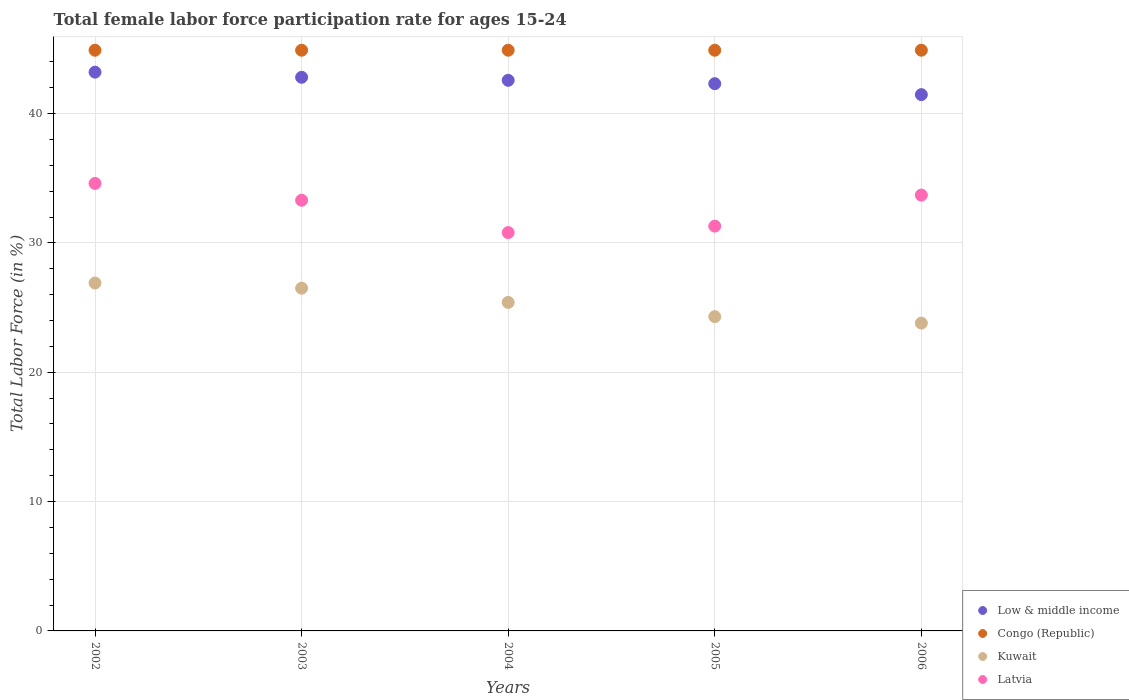How many different coloured dotlines are there?
Your response must be concise. 4. What is the female labor force participation rate in Low & middle income in 2005?
Your response must be concise. 42.31. Across all years, what is the maximum female labor force participation rate in Congo (Republic)?
Make the answer very short. 44.9. Across all years, what is the minimum female labor force participation rate in Kuwait?
Keep it short and to the point. 23.8. In which year was the female labor force participation rate in Kuwait maximum?
Your answer should be compact. 2002. What is the total female labor force participation rate in Congo (Republic) in the graph?
Provide a short and direct response. 224.5. What is the difference between the female labor force participation rate in Low & middle income in 2004 and that in 2006?
Make the answer very short. 1.11. What is the difference between the female labor force participation rate in Congo (Republic) in 2006 and the female labor force participation rate in Low & middle income in 2004?
Give a very brief answer. 2.33. What is the average female labor force participation rate in Low & middle income per year?
Offer a very short reply. 42.47. In the year 2006, what is the difference between the female labor force participation rate in Congo (Republic) and female labor force participation rate in Low & middle income?
Your answer should be very brief. 3.43. In how many years, is the female labor force participation rate in Congo (Republic) greater than 30 %?
Keep it short and to the point. 5. What is the ratio of the female labor force participation rate in Low & middle income in 2003 to that in 2004?
Offer a terse response. 1.01. What is the difference between the highest and the second highest female labor force participation rate in Congo (Republic)?
Offer a very short reply. 0. What is the difference between the highest and the lowest female labor force participation rate in Congo (Republic)?
Offer a very short reply. 0. In how many years, is the female labor force participation rate in Kuwait greater than the average female labor force participation rate in Kuwait taken over all years?
Provide a succinct answer. 3. Does the female labor force participation rate in Latvia monotonically increase over the years?
Provide a short and direct response. No. Is the female labor force participation rate in Kuwait strictly greater than the female labor force participation rate in Congo (Republic) over the years?
Provide a succinct answer. No. Does the graph contain any zero values?
Ensure brevity in your answer.  No. Does the graph contain grids?
Ensure brevity in your answer.  Yes. How are the legend labels stacked?
Your answer should be very brief. Vertical. What is the title of the graph?
Provide a short and direct response. Total female labor force participation rate for ages 15-24. What is the label or title of the Y-axis?
Your response must be concise. Total Labor Force (in %). What is the Total Labor Force (in %) of Low & middle income in 2002?
Your answer should be very brief. 43.2. What is the Total Labor Force (in %) in Congo (Republic) in 2002?
Give a very brief answer. 44.9. What is the Total Labor Force (in %) in Kuwait in 2002?
Ensure brevity in your answer.  26.9. What is the Total Labor Force (in %) of Latvia in 2002?
Your answer should be very brief. 34.6. What is the Total Labor Force (in %) of Low & middle income in 2003?
Your response must be concise. 42.81. What is the Total Labor Force (in %) of Congo (Republic) in 2003?
Your answer should be very brief. 44.9. What is the Total Labor Force (in %) in Latvia in 2003?
Ensure brevity in your answer.  33.3. What is the Total Labor Force (in %) of Low & middle income in 2004?
Ensure brevity in your answer.  42.57. What is the Total Labor Force (in %) in Congo (Republic) in 2004?
Your response must be concise. 44.9. What is the Total Labor Force (in %) of Kuwait in 2004?
Your answer should be compact. 25.4. What is the Total Labor Force (in %) in Latvia in 2004?
Offer a very short reply. 30.8. What is the Total Labor Force (in %) of Low & middle income in 2005?
Provide a succinct answer. 42.31. What is the Total Labor Force (in %) of Congo (Republic) in 2005?
Your response must be concise. 44.9. What is the Total Labor Force (in %) of Kuwait in 2005?
Provide a short and direct response. 24.3. What is the Total Labor Force (in %) in Latvia in 2005?
Your response must be concise. 31.3. What is the Total Labor Force (in %) in Low & middle income in 2006?
Make the answer very short. 41.47. What is the Total Labor Force (in %) of Congo (Republic) in 2006?
Keep it short and to the point. 44.9. What is the Total Labor Force (in %) of Kuwait in 2006?
Give a very brief answer. 23.8. What is the Total Labor Force (in %) in Latvia in 2006?
Provide a succinct answer. 33.7. Across all years, what is the maximum Total Labor Force (in %) in Low & middle income?
Offer a terse response. 43.2. Across all years, what is the maximum Total Labor Force (in %) of Congo (Republic)?
Your answer should be very brief. 44.9. Across all years, what is the maximum Total Labor Force (in %) in Kuwait?
Keep it short and to the point. 26.9. Across all years, what is the maximum Total Labor Force (in %) of Latvia?
Ensure brevity in your answer.  34.6. Across all years, what is the minimum Total Labor Force (in %) in Low & middle income?
Ensure brevity in your answer.  41.47. Across all years, what is the minimum Total Labor Force (in %) of Congo (Republic)?
Keep it short and to the point. 44.9. Across all years, what is the minimum Total Labor Force (in %) in Kuwait?
Your answer should be compact. 23.8. Across all years, what is the minimum Total Labor Force (in %) of Latvia?
Your answer should be very brief. 30.8. What is the total Total Labor Force (in %) of Low & middle income in the graph?
Make the answer very short. 212.36. What is the total Total Labor Force (in %) of Congo (Republic) in the graph?
Provide a short and direct response. 224.5. What is the total Total Labor Force (in %) in Kuwait in the graph?
Offer a terse response. 126.9. What is the total Total Labor Force (in %) of Latvia in the graph?
Your answer should be compact. 163.7. What is the difference between the Total Labor Force (in %) of Low & middle income in 2002 and that in 2003?
Ensure brevity in your answer.  0.4. What is the difference between the Total Labor Force (in %) of Latvia in 2002 and that in 2003?
Your answer should be very brief. 1.3. What is the difference between the Total Labor Force (in %) of Low & middle income in 2002 and that in 2004?
Your response must be concise. 0.63. What is the difference between the Total Labor Force (in %) of Congo (Republic) in 2002 and that in 2004?
Offer a terse response. 0. What is the difference between the Total Labor Force (in %) of Kuwait in 2002 and that in 2004?
Provide a succinct answer. 1.5. What is the difference between the Total Labor Force (in %) in Latvia in 2002 and that in 2004?
Give a very brief answer. 3.8. What is the difference between the Total Labor Force (in %) of Low & middle income in 2002 and that in 2005?
Offer a very short reply. 0.89. What is the difference between the Total Labor Force (in %) of Kuwait in 2002 and that in 2005?
Keep it short and to the point. 2.6. What is the difference between the Total Labor Force (in %) of Latvia in 2002 and that in 2005?
Ensure brevity in your answer.  3.3. What is the difference between the Total Labor Force (in %) in Low & middle income in 2002 and that in 2006?
Provide a short and direct response. 1.74. What is the difference between the Total Labor Force (in %) of Congo (Republic) in 2002 and that in 2006?
Ensure brevity in your answer.  0. What is the difference between the Total Labor Force (in %) of Latvia in 2002 and that in 2006?
Offer a terse response. 0.9. What is the difference between the Total Labor Force (in %) of Low & middle income in 2003 and that in 2004?
Your answer should be compact. 0.23. What is the difference between the Total Labor Force (in %) of Kuwait in 2003 and that in 2004?
Make the answer very short. 1.1. What is the difference between the Total Labor Force (in %) in Low & middle income in 2003 and that in 2005?
Your answer should be very brief. 0.49. What is the difference between the Total Labor Force (in %) of Congo (Republic) in 2003 and that in 2005?
Provide a succinct answer. 0. What is the difference between the Total Labor Force (in %) in Latvia in 2003 and that in 2005?
Provide a succinct answer. 2. What is the difference between the Total Labor Force (in %) of Low & middle income in 2003 and that in 2006?
Provide a succinct answer. 1.34. What is the difference between the Total Labor Force (in %) in Congo (Republic) in 2003 and that in 2006?
Your answer should be very brief. 0. What is the difference between the Total Labor Force (in %) of Kuwait in 2003 and that in 2006?
Ensure brevity in your answer.  2.7. What is the difference between the Total Labor Force (in %) in Latvia in 2003 and that in 2006?
Offer a terse response. -0.4. What is the difference between the Total Labor Force (in %) in Low & middle income in 2004 and that in 2005?
Ensure brevity in your answer.  0.26. What is the difference between the Total Labor Force (in %) of Congo (Republic) in 2004 and that in 2005?
Your answer should be compact. 0. What is the difference between the Total Labor Force (in %) of Kuwait in 2004 and that in 2005?
Provide a succinct answer. 1.1. What is the difference between the Total Labor Force (in %) in Low & middle income in 2004 and that in 2006?
Offer a terse response. 1.11. What is the difference between the Total Labor Force (in %) in Congo (Republic) in 2004 and that in 2006?
Offer a terse response. 0. What is the difference between the Total Labor Force (in %) in Kuwait in 2004 and that in 2006?
Your answer should be compact. 1.6. What is the difference between the Total Labor Force (in %) in Latvia in 2004 and that in 2006?
Provide a short and direct response. -2.9. What is the difference between the Total Labor Force (in %) in Low & middle income in 2005 and that in 2006?
Ensure brevity in your answer.  0.85. What is the difference between the Total Labor Force (in %) in Congo (Republic) in 2005 and that in 2006?
Your answer should be compact. 0. What is the difference between the Total Labor Force (in %) in Latvia in 2005 and that in 2006?
Your answer should be very brief. -2.4. What is the difference between the Total Labor Force (in %) in Low & middle income in 2002 and the Total Labor Force (in %) in Congo (Republic) in 2003?
Your answer should be very brief. -1.7. What is the difference between the Total Labor Force (in %) in Low & middle income in 2002 and the Total Labor Force (in %) in Kuwait in 2003?
Give a very brief answer. 16.7. What is the difference between the Total Labor Force (in %) in Low & middle income in 2002 and the Total Labor Force (in %) in Latvia in 2003?
Keep it short and to the point. 9.9. What is the difference between the Total Labor Force (in %) of Congo (Republic) in 2002 and the Total Labor Force (in %) of Latvia in 2003?
Your answer should be compact. 11.6. What is the difference between the Total Labor Force (in %) in Kuwait in 2002 and the Total Labor Force (in %) in Latvia in 2003?
Give a very brief answer. -6.4. What is the difference between the Total Labor Force (in %) in Low & middle income in 2002 and the Total Labor Force (in %) in Congo (Republic) in 2004?
Provide a succinct answer. -1.7. What is the difference between the Total Labor Force (in %) in Low & middle income in 2002 and the Total Labor Force (in %) in Kuwait in 2004?
Ensure brevity in your answer.  17.8. What is the difference between the Total Labor Force (in %) in Low & middle income in 2002 and the Total Labor Force (in %) in Latvia in 2004?
Provide a succinct answer. 12.4. What is the difference between the Total Labor Force (in %) of Kuwait in 2002 and the Total Labor Force (in %) of Latvia in 2004?
Provide a short and direct response. -3.9. What is the difference between the Total Labor Force (in %) of Low & middle income in 2002 and the Total Labor Force (in %) of Congo (Republic) in 2005?
Ensure brevity in your answer.  -1.7. What is the difference between the Total Labor Force (in %) in Low & middle income in 2002 and the Total Labor Force (in %) in Kuwait in 2005?
Provide a short and direct response. 18.9. What is the difference between the Total Labor Force (in %) in Low & middle income in 2002 and the Total Labor Force (in %) in Latvia in 2005?
Keep it short and to the point. 11.9. What is the difference between the Total Labor Force (in %) of Congo (Republic) in 2002 and the Total Labor Force (in %) of Kuwait in 2005?
Your answer should be very brief. 20.6. What is the difference between the Total Labor Force (in %) of Kuwait in 2002 and the Total Labor Force (in %) of Latvia in 2005?
Provide a short and direct response. -4.4. What is the difference between the Total Labor Force (in %) in Low & middle income in 2002 and the Total Labor Force (in %) in Congo (Republic) in 2006?
Provide a short and direct response. -1.7. What is the difference between the Total Labor Force (in %) in Low & middle income in 2002 and the Total Labor Force (in %) in Kuwait in 2006?
Ensure brevity in your answer.  19.4. What is the difference between the Total Labor Force (in %) in Low & middle income in 2002 and the Total Labor Force (in %) in Latvia in 2006?
Provide a short and direct response. 9.5. What is the difference between the Total Labor Force (in %) in Congo (Republic) in 2002 and the Total Labor Force (in %) in Kuwait in 2006?
Keep it short and to the point. 21.1. What is the difference between the Total Labor Force (in %) in Congo (Republic) in 2002 and the Total Labor Force (in %) in Latvia in 2006?
Provide a succinct answer. 11.2. What is the difference between the Total Labor Force (in %) in Low & middle income in 2003 and the Total Labor Force (in %) in Congo (Republic) in 2004?
Keep it short and to the point. -2.09. What is the difference between the Total Labor Force (in %) of Low & middle income in 2003 and the Total Labor Force (in %) of Kuwait in 2004?
Provide a succinct answer. 17.41. What is the difference between the Total Labor Force (in %) in Low & middle income in 2003 and the Total Labor Force (in %) in Latvia in 2004?
Offer a terse response. 12.01. What is the difference between the Total Labor Force (in %) in Congo (Republic) in 2003 and the Total Labor Force (in %) in Latvia in 2004?
Make the answer very short. 14.1. What is the difference between the Total Labor Force (in %) of Low & middle income in 2003 and the Total Labor Force (in %) of Congo (Republic) in 2005?
Your answer should be very brief. -2.09. What is the difference between the Total Labor Force (in %) in Low & middle income in 2003 and the Total Labor Force (in %) in Kuwait in 2005?
Your response must be concise. 18.51. What is the difference between the Total Labor Force (in %) of Low & middle income in 2003 and the Total Labor Force (in %) of Latvia in 2005?
Provide a succinct answer. 11.51. What is the difference between the Total Labor Force (in %) of Congo (Republic) in 2003 and the Total Labor Force (in %) of Kuwait in 2005?
Give a very brief answer. 20.6. What is the difference between the Total Labor Force (in %) of Congo (Republic) in 2003 and the Total Labor Force (in %) of Latvia in 2005?
Provide a succinct answer. 13.6. What is the difference between the Total Labor Force (in %) of Kuwait in 2003 and the Total Labor Force (in %) of Latvia in 2005?
Offer a terse response. -4.8. What is the difference between the Total Labor Force (in %) in Low & middle income in 2003 and the Total Labor Force (in %) in Congo (Republic) in 2006?
Provide a succinct answer. -2.09. What is the difference between the Total Labor Force (in %) of Low & middle income in 2003 and the Total Labor Force (in %) of Kuwait in 2006?
Your answer should be very brief. 19.01. What is the difference between the Total Labor Force (in %) in Low & middle income in 2003 and the Total Labor Force (in %) in Latvia in 2006?
Keep it short and to the point. 9.11. What is the difference between the Total Labor Force (in %) in Congo (Republic) in 2003 and the Total Labor Force (in %) in Kuwait in 2006?
Provide a short and direct response. 21.1. What is the difference between the Total Labor Force (in %) in Congo (Republic) in 2003 and the Total Labor Force (in %) in Latvia in 2006?
Offer a terse response. 11.2. What is the difference between the Total Labor Force (in %) of Low & middle income in 2004 and the Total Labor Force (in %) of Congo (Republic) in 2005?
Your answer should be compact. -2.33. What is the difference between the Total Labor Force (in %) in Low & middle income in 2004 and the Total Labor Force (in %) in Kuwait in 2005?
Provide a succinct answer. 18.27. What is the difference between the Total Labor Force (in %) in Low & middle income in 2004 and the Total Labor Force (in %) in Latvia in 2005?
Your answer should be very brief. 11.27. What is the difference between the Total Labor Force (in %) of Congo (Republic) in 2004 and the Total Labor Force (in %) of Kuwait in 2005?
Make the answer very short. 20.6. What is the difference between the Total Labor Force (in %) in Congo (Republic) in 2004 and the Total Labor Force (in %) in Latvia in 2005?
Offer a terse response. 13.6. What is the difference between the Total Labor Force (in %) of Kuwait in 2004 and the Total Labor Force (in %) of Latvia in 2005?
Your answer should be very brief. -5.9. What is the difference between the Total Labor Force (in %) of Low & middle income in 2004 and the Total Labor Force (in %) of Congo (Republic) in 2006?
Provide a succinct answer. -2.33. What is the difference between the Total Labor Force (in %) in Low & middle income in 2004 and the Total Labor Force (in %) in Kuwait in 2006?
Offer a terse response. 18.77. What is the difference between the Total Labor Force (in %) in Low & middle income in 2004 and the Total Labor Force (in %) in Latvia in 2006?
Make the answer very short. 8.87. What is the difference between the Total Labor Force (in %) in Congo (Republic) in 2004 and the Total Labor Force (in %) in Kuwait in 2006?
Ensure brevity in your answer.  21.1. What is the difference between the Total Labor Force (in %) of Low & middle income in 2005 and the Total Labor Force (in %) of Congo (Republic) in 2006?
Your answer should be very brief. -2.59. What is the difference between the Total Labor Force (in %) of Low & middle income in 2005 and the Total Labor Force (in %) of Kuwait in 2006?
Give a very brief answer. 18.51. What is the difference between the Total Labor Force (in %) in Low & middle income in 2005 and the Total Labor Force (in %) in Latvia in 2006?
Give a very brief answer. 8.61. What is the difference between the Total Labor Force (in %) in Congo (Republic) in 2005 and the Total Labor Force (in %) in Kuwait in 2006?
Ensure brevity in your answer.  21.1. What is the difference between the Total Labor Force (in %) in Kuwait in 2005 and the Total Labor Force (in %) in Latvia in 2006?
Offer a very short reply. -9.4. What is the average Total Labor Force (in %) of Low & middle income per year?
Ensure brevity in your answer.  42.47. What is the average Total Labor Force (in %) of Congo (Republic) per year?
Ensure brevity in your answer.  44.9. What is the average Total Labor Force (in %) of Kuwait per year?
Your response must be concise. 25.38. What is the average Total Labor Force (in %) in Latvia per year?
Offer a very short reply. 32.74. In the year 2002, what is the difference between the Total Labor Force (in %) in Low & middle income and Total Labor Force (in %) in Congo (Republic)?
Offer a terse response. -1.7. In the year 2002, what is the difference between the Total Labor Force (in %) of Low & middle income and Total Labor Force (in %) of Kuwait?
Ensure brevity in your answer.  16.3. In the year 2002, what is the difference between the Total Labor Force (in %) in Low & middle income and Total Labor Force (in %) in Latvia?
Your answer should be compact. 8.6. In the year 2002, what is the difference between the Total Labor Force (in %) in Congo (Republic) and Total Labor Force (in %) in Kuwait?
Keep it short and to the point. 18. In the year 2002, what is the difference between the Total Labor Force (in %) of Kuwait and Total Labor Force (in %) of Latvia?
Keep it short and to the point. -7.7. In the year 2003, what is the difference between the Total Labor Force (in %) of Low & middle income and Total Labor Force (in %) of Congo (Republic)?
Provide a succinct answer. -2.09. In the year 2003, what is the difference between the Total Labor Force (in %) in Low & middle income and Total Labor Force (in %) in Kuwait?
Provide a short and direct response. 16.31. In the year 2003, what is the difference between the Total Labor Force (in %) in Low & middle income and Total Labor Force (in %) in Latvia?
Give a very brief answer. 9.51. In the year 2003, what is the difference between the Total Labor Force (in %) in Congo (Republic) and Total Labor Force (in %) in Kuwait?
Give a very brief answer. 18.4. In the year 2003, what is the difference between the Total Labor Force (in %) in Kuwait and Total Labor Force (in %) in Latvia?
Keep it short and to the point. -6.8. In the year 2004, what is the difference between the Total Labor Force (in %) of Low & middle income and Total Labor Force (in %) of Congo (Republic)?
Ensure brevity in your answer.  -2.33. In the year 2004, what is the difference between the Total Labor Force (in %) of Low & middle income and Total Labor Force (in %) of Kuwait?
Your answer should be very brief. 17.17. In the year 2004, what is the difference between the Total Labor Force (in %) of Low & middle income and Total Labor Force (in %) of Latvia?
Offer a terse response. 11.77. In the year 2004, what is the difference between the Total Labor Force (in %) in Congo (Republic) and Total Labor Force (in %) in Kuwait?
Offer a terse response. 19.5. In the year 2004, what is the difference between the Total Labor Force (in %) in Congo (Republic) and Total Labor Force (in %) in Latvia?
Your answer should be very brief. 14.1. In the year 2005, what is the difference between the Total Labor Force (in %) of Low & middle income and Total Labor Force (in %) of Congo (Republic)?
Ensure brevity in your answer.  -2.59. In the year 2005, what is the difference between the Total Labor Force (in %) in Low & middle income and Total Labor Force (in %) in Kuwait?
Provide a succinct answer. 18.01. In the year 2005, what is the difference between the Total Labor Force (in %) in Low & middle income and Total Labor Force (in %) in Latvia?
Provide a succinct answer. 11.01. In the year 2005, what is the difference between the Total Labor Force (in %) of Congo (Republic) and Total Labor Force (in %) of Kuwait?
Give a very brief answer. 20.6. In the year 2005, what is the difference between the Total Labor Force (in %) in Congo (Republic) and Total Labor Force (in %) in Latvia?
Provide a succinct answer. 13.6. In the year 2006, what is the difference between the Total Labor Force (in %) in Low & middle income and Total Labor Force (in %) in Congo (Republic)?
Provide a short and direct response. -3.43. In the year 2006, what is the difference between the Total Labor Force (in %) of Low & middle income and Total Labor Force (in %) of Kuwait?
Make the answer very short. 17.67. In the year 2006, what is the difference between the Total Labor Force (in %) of Low & middle income and Total Labor Force (in %) of Latvia?
Offer a terse response. 7.77. In the year 2006, what is the difference between the Total Labor Force (in %) in Congo (Republic) and Total Labor Force (in %) in Kuwait?
Your answer should be very brief. 21.1. What is the ratio of the Total Labor Force (in %) in Low & middle income in 2002 to that in 2003?
Your answer should be compact. 1.01. What is the ratio of the Total Labor Force (in %) in Kuwait in 2002 to that in 2003?
Ensure brevity in your answer.  1.02. What is the ratio of the Total Labor Force (in %) of Latvia in 2002 to that in 2003?
Your response must be concise. 1.04. What is the ratio of the Total Labor Force (in %) in Low & middle income in 2002 to that in 2004?
Offer a terse response. 1.01. What is the ratio of the Total Labor Force (in %) in Congo (Republic) in 2002 to that in 2004?
Keep it short and to the point. 1. What is the ratio of the Total Labor Force (in %) in Kuwait in 2002 to that in 2004?
Your answer should be very brief. 1.06. What is the ratio of the Total Labor Force (in %) of Latvia in 2002 to that in 2004?
Provide a succinct answer. 1.12. What is the ratio of the Total Labor Force (in %) in Low & middle income in 2002 to that in 2005?
Provide a succinct answer. 1.02. What is the ratio of the Total Labor Force (in %) in Congo (Republic) in 2002 to that in 2005?
Provide a succinct answer. 1. What is the ratio of the Total Labor Force (in %) in Kuwait in 2002 to that in 2005?
Make the answer very short. 1.11. What is the ratio of the Total Labor Force (in %) of Latvia in 2002 to that in 2005?
Make the answer very short. 1.11. What is the ratio of the Total Labor Force (in %) of Low & middle income in 2002 to that in 2006?
Your answer should be very brief. 1.04. What is the ratio of the Total Labor Force (in %) in Kuwait in 2002 to that in 2006?
Your answer should be very brief. 1.13. What is the ratio of the Total Labor Force (in %) in Latvia in 2002 to that in 2006?
Your response must be concise. 1.03. What is the ratio of the Total Labor Force (in %) of Kuwait in 2003 to that in 2004?
Your answer should be very brief. 1.04. What is the ratio of the Total Labor Force (in %) of Latvia in 2003 to that in 2004?
Offer a terse response. 1.08. What is the ratio of the Total Labor Force (in %) in Low & middle income in 2003 to that in 2005?
Offer a very short reply. 1.01. What is the ratio of the Total Labor Force (in %) of Kuwait in 2003 to that in 2005?
Offer a very short reply. 1.09. What is the ratio of the Total Labor Force (in %) in Latvia in 2003 to that in 2005?
Your response must be concise. 1.06. What is the ratio of the Total Labor Force (in %) in Low & middle income in 2003 to that in 2006?
Ensure brevity in your answer.  1.03. What is the ratio of the Total Labor Force (in %) of Kuwait in 2003 to that in 2006?
Give a very brief answer. 1.11. What is the ratio of the Total Labor Force (in %) of Kuwait in 2004 to that in 2005?
Offer a very short reply. 1.05. What is the ratio of the Total Labor Force (in %) in Low & middle income in 2004 to that in 2006?
Offer a very short reply. 1.03. What is the ratio of the Total Labor Force (in %) of Kuwait in 2004 to that in 2006?
Your answer should be very brief. 1.07. What is the ratio of the Total Labor Force (in %) in Latvia in 2004 to that in 2006?
Give a very brief answer. 0.91. What is the ratio of the Total Labor Force (in %) of Low & middle income in 2005 to that in 2006?
Make the answer very short. 1.02. What is the ratio of the Total Labor Force (in %) of Congo (Republic) in 2005 to that in 2006?
Give a very brief answer. 1. What is the ratio of the Total Labor Force (in %) of Kuwait in 2005 to that in 2006?
Make the answer very short. 1.02. What is the ratio of the Total Labor Force (in %) in Latvia in 2005 to that in 2006?
Provide a succinct answer. 0.93. What is the difference between the highest and the second highest Total Labor Force (in %) in Low & middle income?
Offer a terse response. 0.4. What is the difference between the highest and the lowest Total Labor Force (in %) of Low & middle income?
Provide a succinct answer. 1.74. What is the difference between the highest and the lowest Total Labor Force (in %) of Congo (Republic)?
Provide a succinct answer. 0. What is the difference between the highest and the lowest Total Labor Force (in %) in Latvia?
Your answer should be very brief. 3.8. 